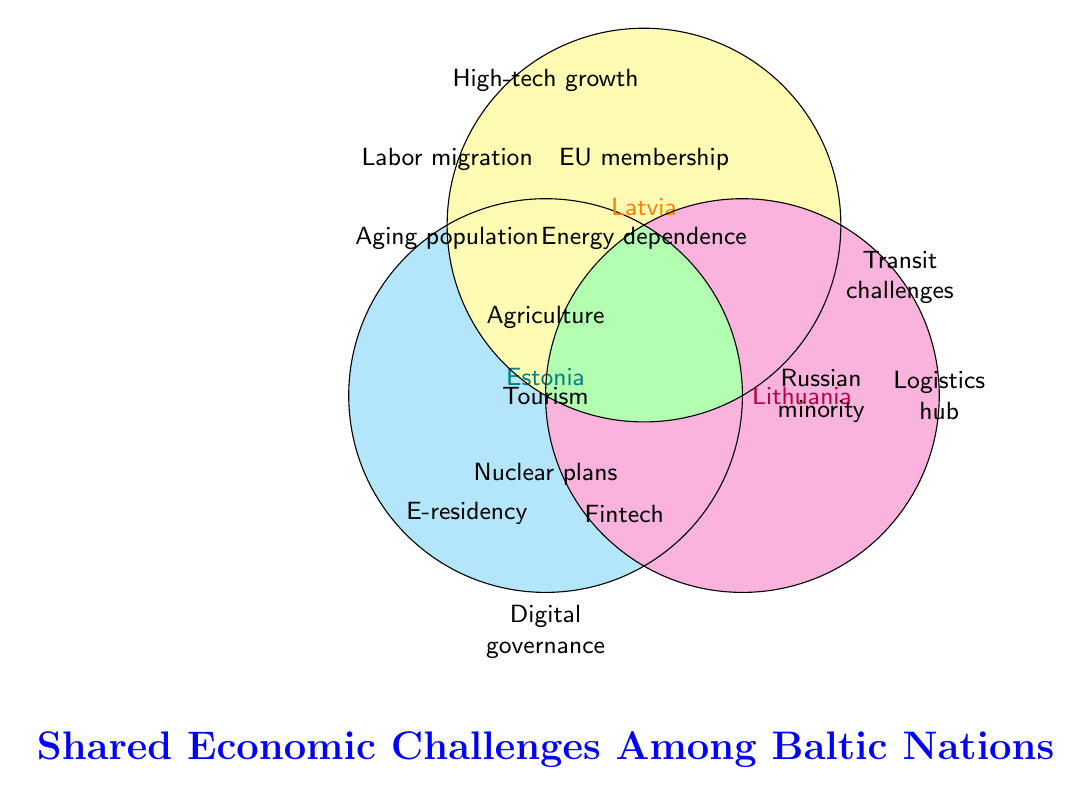What are the shared economic challenges among Estonia, Latvia, and Lithuania? The shared economic challenges are represented in the overlapping section of all three circles in the Venn diagram. This includes: High-tech sector growth, EU membership, Energy dependence on Russia, Labor migration, Aging population, Agricultural sector importance, Tourism development, and Nuclear energy plans.
Answer: High-tech sector growth, EU membership, Energy dependence on Russia, Labor migration, Aging population, Agricultural sector importance, Tourism development, Nuclear energy plans Which countries face issues with Labor migration? The issue of Labor migration is listed in the central section where the circles for Estonia, Latvia, and Lithuania overlap. This indicates it is common to all three countries.
Answer: Estonia, Latvia, Lithuania Does Estonia have any unique economic challenges not shared with Latvia and Lithuania? By looking at the section of the Venn diagram that only represents Estonia (i.e., outside the overlapping areas), we can find unique challenges. These include: Digital governance, E-residency program, Oil shale industry, and Fintech innovation.
Answer: Digital governance, E-residency program, Oil shale industry, Fintech innovation Which countries consider Transit sector challenges significant? The Transit sector challenges are located in the overlapping area of Latvia and Lithuania, not Estonia. So, the countries facing Transit sector challenges are Latvia and Lithuania.
Answer: Latvia, Lithuania How many economic challenges are unique to Lithuania according to the diagram? The unique challenges for Lithuania can be found in the section of the Venn diagram representing Lithuania alone. There are three unique challenges: Large Russian-speaking minority, Forest industry, and Logistics hub potential.
Answer: 3 Does Latvia consider the Forest industry or Oil shale industry an economic challenge? According to the Venn diagram, the Forest industry is listed specifically for Lithuania, and the Oil shale industry for Estonia. Latvia does not consider either a distinct economic challenge.
Answer: No Compare the economic challenges of Estonia and Latvia. Do they share any that are not shared with Lithuania? To compare, we look at the overlapping part between Estonia and Latvia that excludes Lithuania. However, in this context, there are no areas indicating direct overlap between only Estonia and Latvia to identify exclusive shared challenges. They share all their challenges with Lithuania or have unique ones.
Answer: No Which countries share Economic dependence on Russia as a challenge? This challenge is located in the central overlapping section of the Venn diagram representing the common challenges among Estonia, Latvia, and Lithuania. Therefore, Economic dependence on Russia is a challenge for all three countries.
Answer: Estonia, Latvia, Lithuania What exclusive challenges does Latvia face that are not shared with Estonia and Lithuania? The section of the Venn diagram exclusive to Latvia lists no unique economic challenges that are not shared with other countries. Latvia’s challenges are either shared or not specified separately from other countries.
Answer: None 